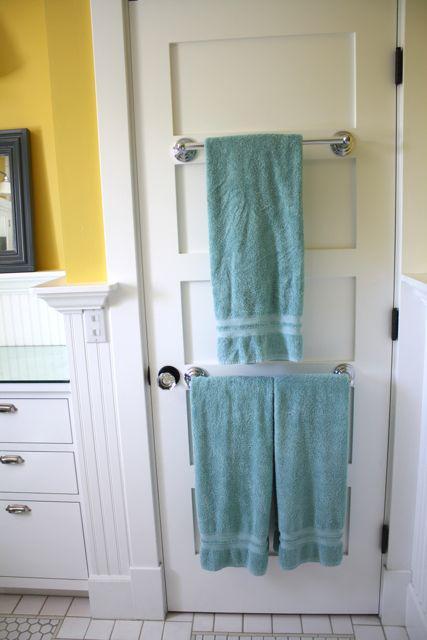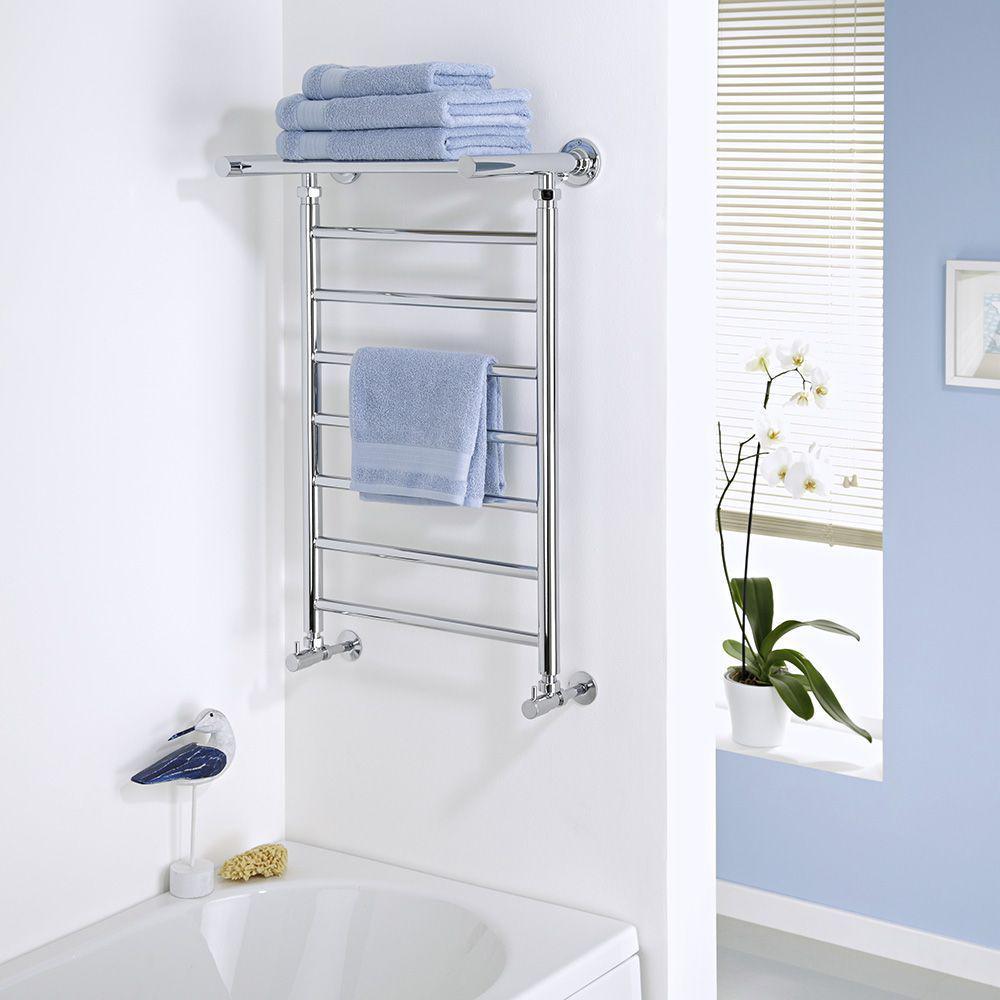The first image is the image on the left, the second image is the image on the right. Assess this claim about the two images: "white towels are on a rack on the floor". Correct or not? Answer yes or no. No. The first image is the image on the left, the second image is the image on the right. Examine the images to the left and right. Is the description "Every towel shown is hanging." accurate? Answer yes or no. No. 